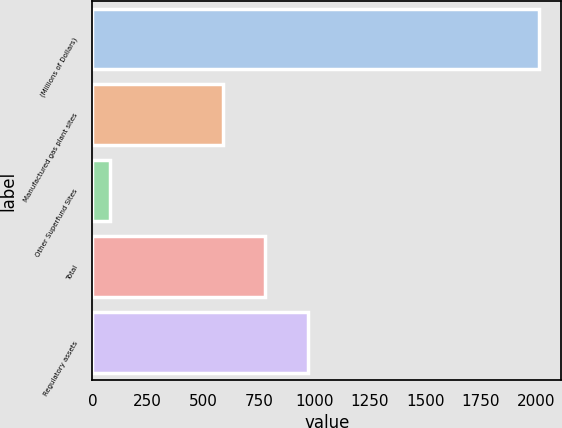Convert chart. <chart><loc_0><loc_0><loc_500><loc_500><bar_chart><fcel>(Millions of Dollars)<fcel>Manufactured gas plant sites<fcel>Other Superfund Sites<fcel>Total<fcel>Regulatory assets<nl><fcel>2014<fcel>587<fcel>79<fcel>780.5<fcel>974<nl></chart> 